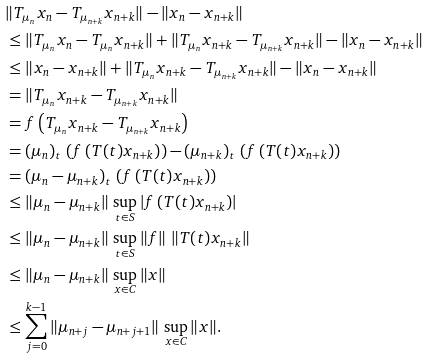<formula> <loc_0><loc_0><loc_500><loc_500>& \| T _ { \mu _ { n } } x _ { n } - T _ { \mu _ { n + k } } x _ { n + k } \| - \| x _ { n } - x _ { n + k } \| \\ & \leq \| T _ { \mu _ { n } } x _ { n } - T _ { \mu _ { n } } x _ { n + k } \| + \| T _ { \mu _ { n } } x _ { n + k } - T _ { \mu _ { n + k } } x _ { n + k } \| - \| x _ { n } - x _ { n + k } \| \\ & \leq \| x _ { n } - x _ { n + k } \| + \| T _ { \mu _ { n } } x _ { n + k } - T _ { \mu _ { n + k } } x _ { n + k } \| - \| x _ { n } - x _ { n + k } \| \\ & = \| T _ { \mu _ { n } } x _ { n + k } - T _ { \mu _ { n + k } } x _ { n + k } \| \\ & = f \left ( T _ { \mu _ { n } } x _ { n + k } - T _ { \mu _ { n + k } } x _ { n + k } \right ) \\ & = ( \mu _ { n } ) _ { t } \, \left ( f \left ( T ( t ) x _ { n + k } \right ) \right ) - ( \mu _ { n + k } ) _ { t } \, \left ( f \left ( T ( t ) x _ { n + k } \right ) \right ) \\ & = ( \mu _ { n } - \mu _ { n + k } ) _ { t } \, \left ( f \left ( T ( t ) x _ { n + k } \right ) \right ) \\ & \leq \| \mu _ { n } - \mu _ { n + k } \| \, \sup _ { t \in S } \left | f \left ( T ( t ) x _ { n + k } \right ) \right | \\ & \leq \| \mu _ { n } - \mu _ { n + k } \| \, \sup _ { t \in S } \| f \| \, \left \| T ( t ) x _ { n + k } \right \| \\ & \leq \| \mu _ { n } - \mu _ { n + k } \| \, \sup _ { x \in C } \| x \| \\ & \leq \sum _ { j = 0 } ^ { k - 1 } \| \mu _ { n + j } - \mu _ { n + j + 1 } \| \, \sup _ { x \in C } \| x \| .</formula> 